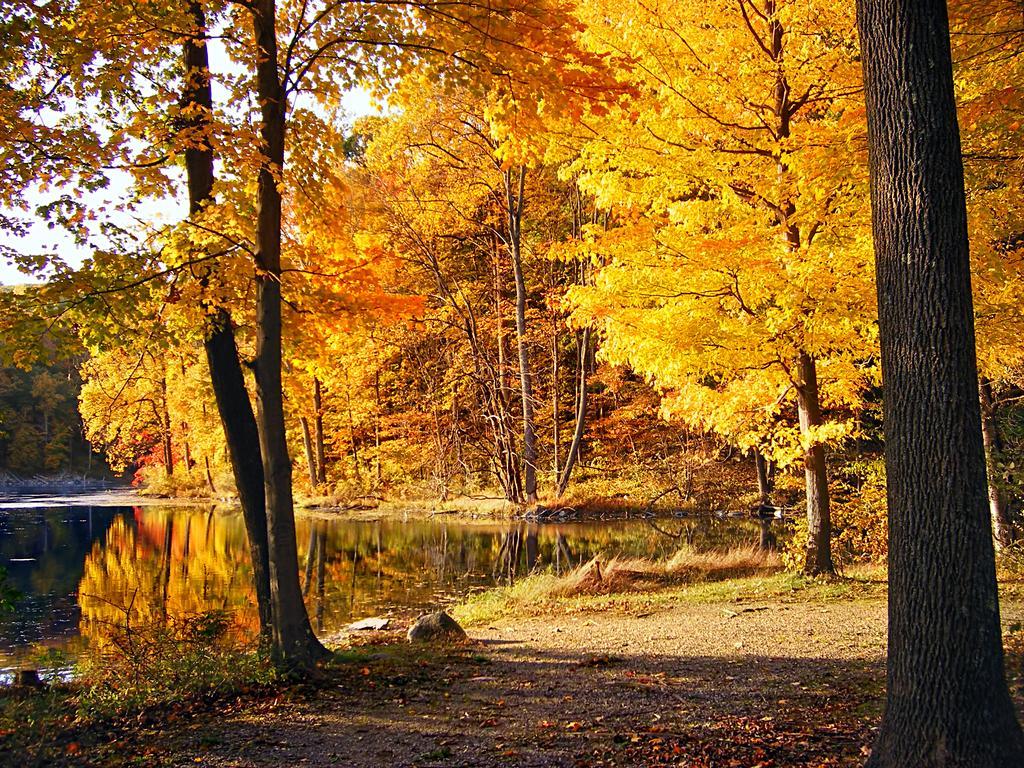Please provide a concise description of this image. In this image I can see many trees which are in yellow and orange color. To the left I can see the water. In the background I can see the sky. 